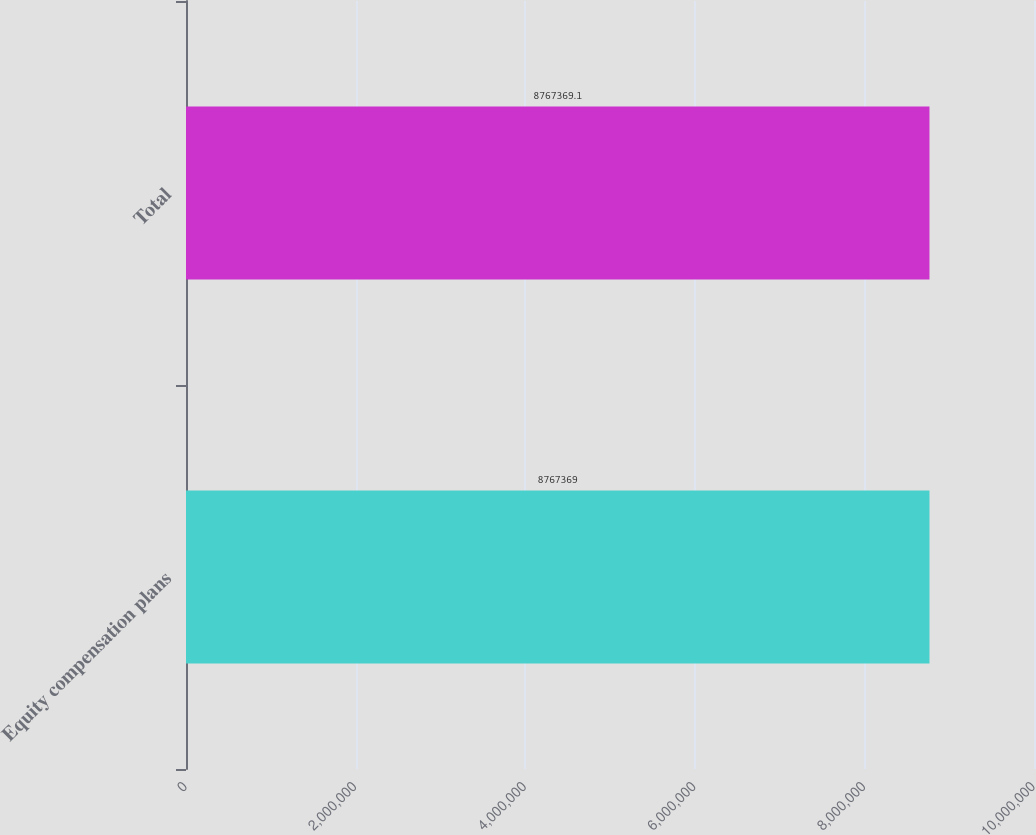Convert chart. <chart><loc_0><loc_0><loc_500><loc_500><bar_chart><fcel>Equity compensation plans<fcel>Total<nl><fcel>8.76737e+06<fcel>8.76737e+06<nl></chart> 